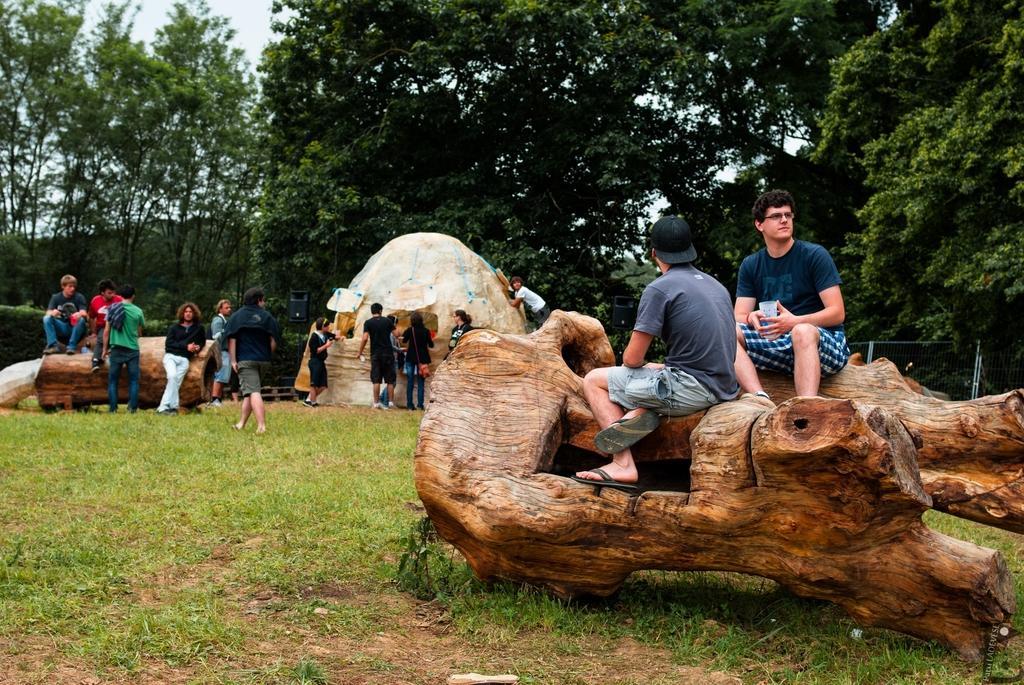Could you give a brief overview of what you see in this image? In this picture I can see group of people among them some are sitting on wooden objects and some are standing on the grass. In the background I can see trees and the sky. 